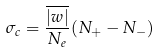<formula> <loc_0><loc_0><loc_500><loc_500>\sigma _ { c } = \frac { \overline { | w | } } { N _ { e } } ( N _ { + } - N _ { - } )</formula> 